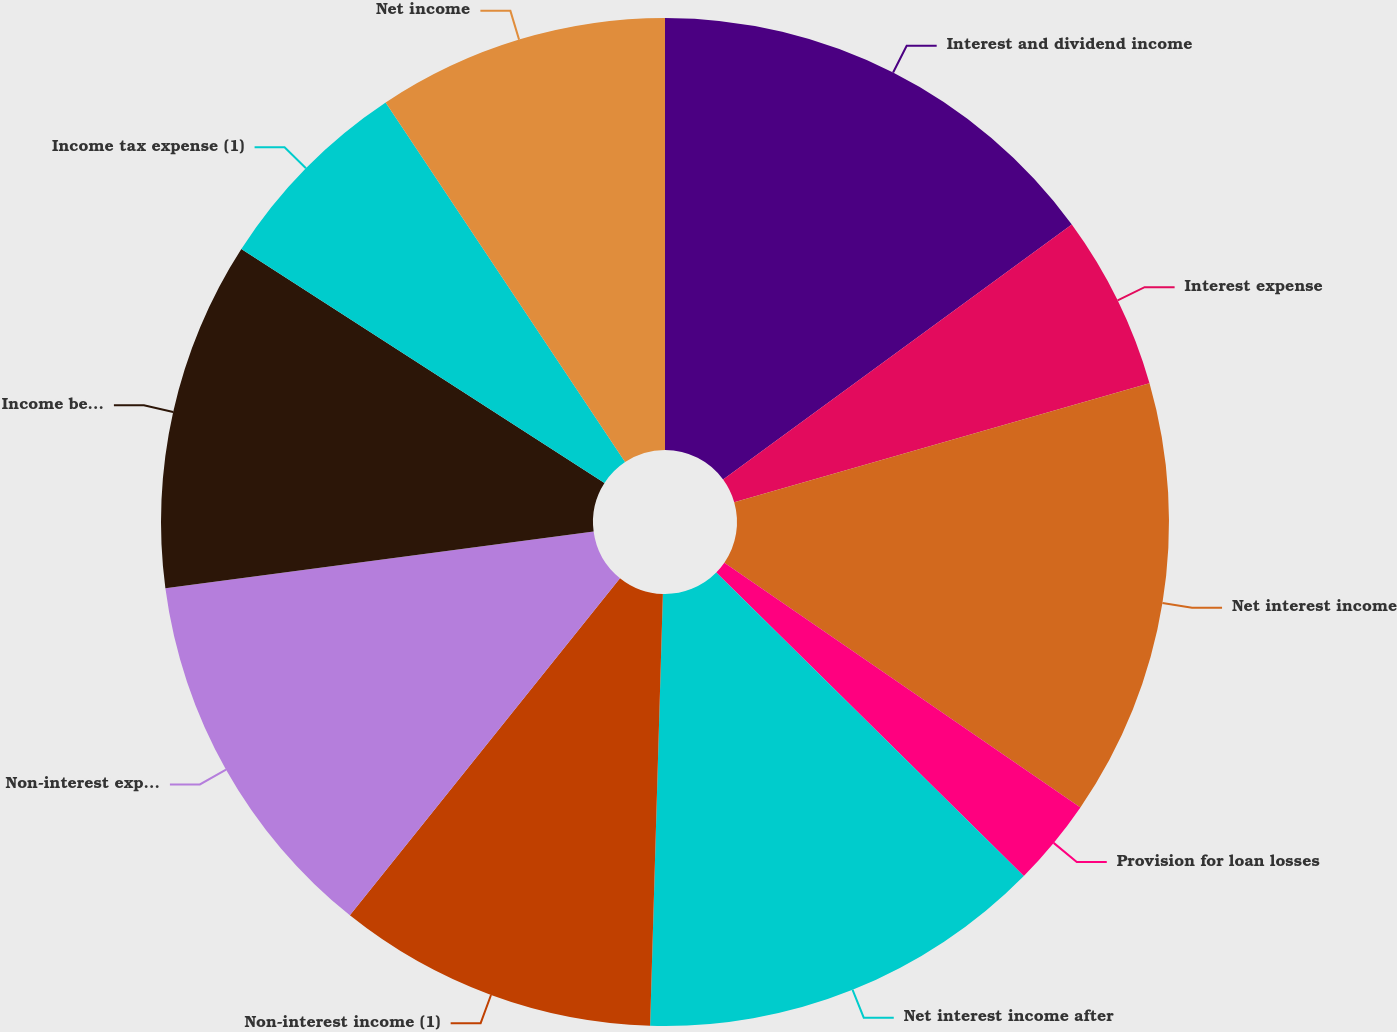Convert chart to OTSL. <chart><loc_0><loc_0><loc_500><loc_500><pie_chart><fcel>Interest and dividend income<fcel>Interest expense<fcel>Net interest income<fcel>Provision for loan losses<fcel>Net interest income after<fcel>Non-interest income (1)<fcel>Non-interest expense<fcel>Income before income tax<fcel>Income tax expense (1)<fcel>Net income<nl><fcel>14.95%<fcel>5.61%<fcel>14.02%<fcel>2.81%<fcel>13.08%<fcel>10.28%<fcel>12.15%<fcel>11.21%<fcel>6.54%<fcel>9.35%<nl></chart> 